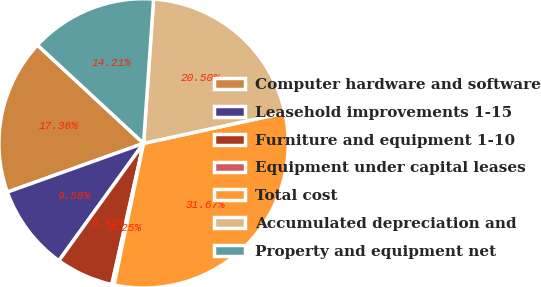Convert chart. <chart><loc_0><loc_0><loc_500><loc_500><pie_chart><fcel>Computer hardware and software<fcel>Leasehold improvements 1-15<fcel>Furniture and equipment 1-10<fcel>Equipment under capital leases<fcel>Total cost<fcel>Accumulated depreciation and<fcel>Property and equipment net<nl><fcel>17.36%<fcel>9.58%<fcel>6.43%<fcel>0.25%<fcel>31.67%<fcel>20.5%<fcel>14.21%<nl></chart> 